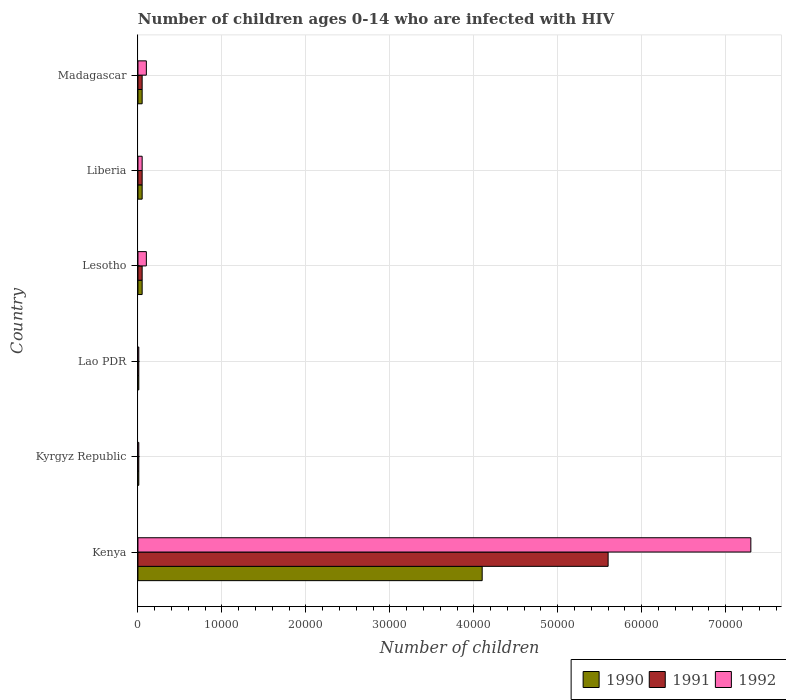How many different coloured bars are there?
Give a very brief answer. 3. Are the number of bars on each tick of the Y-axis equal?
Keep it short and to the point. Yes. What is the label of the 4th group of bars from the top?
Offer a very short reply. Lao PDR. In how many cases, is the number of bars for a given country not equal to the number of legend labels?
Ensure brevity in your answer.  0. What is the number of HIV infected children in 1991 in Kyrgyz Republic?
Keep it short and to the point. 100. Across all countries, what is the maximum number of HIV infected children in 1990?
Offer a terse response. 4.10e+04. Across all countries, what is the minimum number of HIV infected children in 1992?
Your answer should be very brief. 100. In which country was the number of HIV infected children in 1992 maximum?
Offer a very short reply. Kenya. In which country was the number of HIV infected children in 1991 minimum?
Offer a terse response. Kyrgyz Republic. What is the total number of HIV infected children in 1991 in the graph?
Your answer should be very brief. 5.77e+04. What is the difference between the number of HIV infected children in 1990 in Kenya and that in Lao PDR?
Your response must be concise. 4.09e+04. What is the difference between the number of HIV infected children in 1991 in Lao PDR and the number of HIV infected children in 1992 in Kenya?
Keep it short and to the point. -7.29e+04. What is the average number of HIV infected children in 1990 per country?
Keep it short and to the point. 7116.67. What is the difference between the number of HIV infected children in 1991 and number of HIV infected children in 1992 in Lesotho?
Your answer should be very brief. -500. In how many countries, is the number of HIV infected children in 1992 greater than 30000 ?
Provide a short and direct response. 1. What is the ratio of the number of HIV infected children in 1991 in Liberia to that in Madagascar?
Ensure brevity in your answer.  1. Is the difference between the number of HIV infected children in 1991 in Kenya and Liberia greater than the difference between the number of HIV infected children in 1992 in Kenya and Liberia?
Your answer should be compact. No. What is the difference between the highest and the second highest number of HIV infected children in 1992?
Your response must be concise. 7.20e+04. What is the difference between the highest and the lowest number of HIV infected children in 1992?
Your answer should be compact. 7.29e+04. In how many countries, is the number of HIV infected children in 1991 greater than the average number of HIV infected children in 1991 taken over all countries?
Keep it short and to the point. 1. What does the 1st bar from the top in Liberia represents?
Provide a succinct answer. 1992. What does the 1st bar from the bottom in Kyrgyz Republic represents?
Offer a terse response. 1990. Are the values on the major ticks of X-axis written in scientific E-notation?
Ensure brevity in your answer.  No. Where does the legend appear in the graph?
Ensure brevity in your answer.  Bottom right. How many legend labels are there?
Give a very brief answer. 3. How are the legend labels stacked?
Give a very brief answer. Horizontal. What is the title of the graph?
Keep it short and to the point. Number of children ages 0-14 who are infected with HIV. What is the label or title of the X-axis?
Offer a very short reply. Number of children. What is the Number of children of 1990 in Kenya?
Make the answer very short. 4.10e+04. What is the Number of children of 1991 in Kenya?
Provide a succinct answer. 5.60e+04. What is the Number of children of 1992 in Kenya?
Give a very brief answer. 7.30e+04. What is the Number of children in 1990 in Kyrgyz Republic?
Offer a terse response. 100. What is the Number of children in 1990 in Lao PDR?
Give a very brief answer. 100. What is the Number of children in 1991 in Lao PDR?
Offer a very short reply. 100. What is the Number of children in 1992 in Lao PDR?
Your response must be concise. 100. What is the Number of children of 1990 in Lesotho?
Keep it short and to the point. 500. What is the Number of children in 1992 in Lesotho?
Provide a succinct answer. 1000. What is the Number of children of 1991 in Liberia?
Keep it short and to the point. 500. What is the Number of children of 1990 in Madagascar?
Offer a very short reply. 500. What is the Number of children of 1991 in Madagascar?
Your response must be concise. 500. Across all countries, what is the maximum Number of children in 1990?
Keep it short and to the point. 4.10e+04. Across all countries, what is the maximum Number of children in 1991?
Give a very brief answer. 5.60e+04. Across all countries, what is the maximum Number of children in 1992?
Provide a short and direct response. 7.30e+04. What is the total Number of children of 1990 in the graph?
Offer a very short reply. 4.27e+04. What is the total Number of children in 1991 in the graph?
Offer a very short reply. 5.77e+04. What is the total Number of children in 1992 in the graph?
Provide a short and direct response. 7.57e+04. What is the difference between the Number of children of 1990 in Kenya and that in Kyrgyz Republic?
Make the answer very short. 4.09e+04. What is the difference between the Number of children of 1991 in Kenya and that in Kyrgyz Republic?
Keep it short and to the point. 5.59e+04. What is the difference between the Number of children in 1992 in Kenya and that in Kyrgyz Republic?
Offer a very short reply. 7.29e+04. What is the difference between the Number of children in 1990 in Kenya and that in Lao PDR?
Provide a succinct answer. 4.09e+04. What is the difference between the Number of children of 1991 in Kenya and that in Lao PDR?
Keep it short and to the point. 5.59e+04. What is the difference between the Number of children of 1992 in Kenya and that in Lao PDR?
Provide a short and direct response. 7.29e+04. What is the difference between the Number of children in 1990 in Kenya and that in Lesotho?
Keep it short and to the point. 4.05e+04. What is the difference between the Number of children of 1991 in Kenya and that in Lesotho?
Keep it short and to the point. 5.55e+04. What is the difference between the Number of children of 1992 in Kenya and that in Lesotho?
Your answer should be compact. 7.20e+04. What is the difference between the Number of children of 1990 in Kenya and that in Liberia?
Offer a terse response. 4.05e+04. What is the difference between the Number of children of 1991 in Kenya and that in Liberia?
Your response must be concise. 5.55e+04. What is the difference between the Number of children in 1992 in Kenya and that in Liberia?
Ensure brevity in your answer.  7.25e+04. What is the difference between the Number of children of 1990 in Kenya and that in Madagascar?
Your response must be concise. 4.05e+04. What is the difference between the Number of children in 1991 in Kenya and that in Madagascar?
Provide a succinct answer. 5.55e+04. What is the difference between the Number of children of 1992 in Kenya and that in Madagascar?
Make the answer very short. 7.20e+04. What is the difference between the Number of children of 1990 in Kyrgyz Republic and that in Lao PDR?
Your answer should be very brief. 0. What is the difference between the Number of children in 1990 in Kyrgyz Republic and that in Lesotho?
Provide a succinct answer. -400. What is the difference between the Number of children in 1991 in Kyrgyz Republic and that in Lesotho?
Offer a very short reply. -400. What is the difference between the Number of children of 1992 in Kyrgyz Republic and that in Lesotho?
Provide a succinct answer. -900. What is the difference between the Number of children in 1990 in Kyrgyz Republic and that in Liberia?
Your response must be concise. -400. What is the difference between the Number of children of 1991 in Kyrgyz Republic and that in Liberia?
Provide a short and direct response. -400. What is the difference between the Number of children of 1992 in Kyrgyz Republic and that in Liberia?
Provide a short and direct response. -400. What is the difference between the Number of children in 1990 in Kyrgyz Republic and that in Madagascar?
Your answer should be compact. -400. What is the difference between the Number of children of 1991 in Kyrgyz Republic and that in Madagascar?
Ensure brevity in your answer.  -400. What is the difference between the Number of children of 1992 in Kyrgyz Republic and that in Madagascar?
Your answer should be very brief. -900. What is the difference between the Number of children in 1990 in Lao PDR and that in Lesotho?
Offer a terse response. -400. What is the difference between the Number of children in 1991 in Lao PDR and that in Lesotho?
Offer a very short reply. -400. What is the difference between the Number of children of 1992 in Lao PDR and that in Lesotho?
Ensure brevity in your answer.  -900. What is the difference between the Number of children of 1990 in Lao PDR and that in Liberia?
Ensure brevity in your answer.  -400. What is the difference between the Number of children in 1991 in Lao PDR and that in Liberia?
Your response must be concise. -400. What is the difference between the Number of children of 1992 in Lao PDR and that in Liberia?
Offer a terse response. -400. What is the difference between the Number of children of 1990 in Lao PDR and that in Madagascar?
Your answer should be compact. -400. What is the difference between the Number of children of 1991 in Lao PDR and that in Madagascar?
Your answer should be very brief. -400. What is the difference between the Number of children of 1992 in Lao PDR and that in Madagascar?
Offer a very short reply. -900. What is the difference between the Number of children in 1992 in Lesotho and that in Liberia?
Your response must be concise. 500. What is the difference between the Number of children of 1991 in Lesotho and that in Madagascar?
Your answer should be very brief. 0. What is the difference between the Number of children of 1992 in Lesotho and that in Madagascar?
Provide a short and direct response. 0. What is the difference between the Number of children of 1990 in Liberia and that in Madagascar?
Your answer should be compact. 0. What is the difference between the Number of children of 1992 in Liberia and that in Madagascar?
Keep it short and to the point. -500. What is the difference between the Number of children of 1990 in Kenya and the Number of children of 1991 in Kyrgyz Republic?
Your response must be concise. 4.09e+04. What is the difference between the Number of children in 1990 in Kenya and the Number of children in 1992 in Kyrgyz Republic?
Offer a terse response. 4.09e+04. What is the difference between the Number of children of 1991 in Kenya and the Number of children of 1992 in Kyrgyz Republic?
Provide a short and direct response. 5.59e+04. What is the difference between the Number of children of 1990 in Kenya and the Number of children of 1991 in Lao PDR?
Offer a very short reply. 4.09e+04. What is the difference between the Number of children of 1990 in Kenya and the Number of children of 1992 in Lao PDR?
Ensure brevity in your answer.  4.09e+04. What is the difference between the Number of children in 1991 in Kenya and the Number of children in 1992 in Lao PDR?
Make the answer very short. 5.59e+04. What is the difference between the Number of children of 1990 in Kenya and the Number of children of 1991 in Lesotho?
Give a very brief answer. 4.05e+04. What is the difference between the Number of children in 1991 in Kenya and the Number of children in 1992 in Lesotho?
Ensure brevity in your answer.  5.50e+04. What is the difference between the Number of children in 1990 in Kenya and the Number of children in 1991 in Liberia?
Give a very brief answer. 4.05e+04. What is the difference between the Number of children in 1990 in Kenya and the Number of children in 1992 in Liberia?
Offer a very short reply. 4.05e+04. What is the difference between the Number of children in 1991 in Kenya and the Number of children in 1992 in Liberia?
Ensure brevity in your answer.  5.55e+04. What is the difference between the Number of children of 1990 in Kenya and the Number of children of 1991 in Madagascar?
Your answer should be compact. 4.05e+04. What is the difference between the Number of children in 1991 in Kenya and the Number of children in 1992 in Madagascar?
Offer a terse response. 5.50e+04. What is the difference between the Number of children in 1990 in Kyrgyz Republic and the Number of children in 1991 in Lao PDR?
Offer a very short reply. 0. What is the difference between the Number of children in 1990 in Kyrgyz Republic and the Number of children in 1992 in Lao PDR?
Provide a short and direct response. 0. What is the difference between the Number of children in 1991 in Kyrgyz Republic and the Number of children in 1992 in Lao PDR?
Provide a succinct answer. 0. What is the difference between the Number of children in 1990 in Kyrgyz Republic and the Number of children in 1991 in Lesotho?
Give a very brief answer. -400. What is the difference between the Number of children of 1990 in Kyrgyz Republic and the Number of children of 1992 in Lesotho?
Make the answer very short. -900. What is the difference between the Number of children of 1991 in Kyrgyz Republic and the Number of children of 1992 in Lesotho?
Your answer should be compact. -900. What is the difference between the Number of children in 1990 in Kyrgyz Republic and the Number of children in 1991 in Liberia?
Give a very brief answer. -400. What is the difference between the Number of children in 1990 in Kyrgyz Republic and the Number of children in 1992 in Liberia?
Make the answer very short. -400. What is the difference between the Number of children in 1991 in Kyrgyz Republic and the Number of children in 1992 in Liberia?
Give a very brief answer. -400. What is the difference between the Number of children in 1990 in Kyrgyz Republic and the Number of children in 1991 in Madagascar?
Your response must be concise. -400. What is the difference between the Number of children of 1990 in Kyrgyz Republic and the Number of children of 1992 in Madagascar?
Provide a short and direct response. -900. What is the difference between the Number of children of 1991 in Kyrgyz Republic and the Number of children of 1992 in Madagascar?
Your answer should be very brief. -900. What is the difference between the Number of children of 1990 in Lao PDR and the Number of children of 1991 in Lesotho?
Your answer should be compact. -400. What is the difference between the Number of children in 1990 in Lao PDR and the Number of children in 1992 in Lesotho?
Offer a terse response. -900. What is the difference between the Number of children in 1991 in Lao PDR and the Number of children in 1992 in Lesotho?
Offer a very short reply. -900. What is the difference between the Number of children in 1990 in Lao PDR and the Number of children in 1991 in Liberia?
Offer a terse response. -400. What is the difference between the Number of children in 1990 in Lao PDR and the Number of children in 1992 in Liberia?
Ensure brevity in your answer.  -400. What is the difference between the Number of children in 1991 in Lao PDR and the Number of children in 1992 in Liberia?
Provide a short and direct response. -400. What is the difference between the Number of children in 1990 in Lao PDR and the Number of children in 1991 in Madagascar?
Provide a short and direct response. -400. What is the difference between the Number of children in 1990 in Lao PDR and the Number of children in 1992 in Madagascar?
Your response must be concise. -900. What is the difference between the Number of children in 1991 in Lao PDR and the Number of children in 1992 in Madagascar?
Offer a very short reply. -900. What is the difference between the Number of children of 1990 in Lesotho and the Number of children of 1992 in Madagascar?
Ensure brevity in your answer.  -500. What is the difference between the Number of children in 1991 in Lesotho and the Number of children in 1992 in Madagascar?
Provide a short and direct response. -500. What is the difference between the Number of children of 1990 in Liberia and the Number of children of 1991 in Madagascar?
Give a very brief answer. 0. What is the difference between the Number of children of 1990 in Liberia and the Number of children of 1992 in Madagascar?
Give a very brief answer. -500. What is the difference between the Number of children of 1991 in Liberia and the Number of children of 1992 in Madagascar?
Your answer should be very brief. -500. What is the average Number of children of 1990 per country?
Keep it short and to the point. 7116.67. What is the average Number of children of 1991 per country?
Provide a short and direct response. 9616.67. What is the average Number of children of 1992 per country?
Provide a short and direct response. 1.26e+04. What is the difference between the Number of children in 1990 and Number of children in 1991 in Kenya?
Offer a terse response. -1.50e+04. What is the difference between the Number of children of 1990 and Number of children of 1992 in Kenya?
Offer a very short reply. -3.20e+04. What is the difference between the Number of children in 1991 and Number of children in 1992 in Kenya?
Offer a very short reply. -1.70e+04. What is the difference between the Number of children of 1991 and Number of children of 1992 in Kyrgyz Republic?
Your response must be concise. 0. What is the difference between the Number of children in 1990 and Number of children in 1991 in Lao PDR?
Make the answer very short. 0. What is the difference between the Number of children in 1990 and Number of children in 1991 in Lesotho?
Your answer should be very brief. 0. What is the difference between the Number of children of 1990 and Number of children of 1992 in Lesotho?
Ensure brevity in your answer.  -500. What is the difference between the Number of children in 1991 and Number of children in 1992 in Lesotho?
Provide a succinct answer. -500. What is the difference between the Number of children of 1990 and Number of children of 1991 in Liberia?
Your answer should be compact. 0. What is the difference between the Number of children in 1991 and Number of children in 1992 in Liberia?
Provide a succinct answer. 0. What is the difference between the Number of children of 1990 and Number of children of 1991 in Madagascar?
Ensure brevity in your answer.  0. What is the difference between the Number of children of 1990 and Number of children of 1992 in Madagascar?
Your answer should be compact. -500. What is the difference between the Number of children of 1991 and Number of children of 1992 in Madagascar?
Offer a very short reply. -500. What is the ratio of the Number of children in 1990 in Kenya to that in Kyrgyz Republic?
Your response must be concise. 410. What is the ratio of the Number of children of 1991 in Kenya to that in Kyrgyz Republic?
Offer a terse response. 560. What is the ratio of the Number of children in 1992 in Kenya to that in Kyrgyz Republic?
Keep it short and to the point. 730. What is the ratio of the Number of children in 1990 in Kenya to that in Lao PDR?
Your answer should be very brief. 410. What is the ratio of the Number of children in 1991 in Kenya to that in Lao PDR?
Offer a very short reply. 560. What is the ratio of the Number of children of 1992 in Kenya to that in Lao PDR?
Make the answer very short. 730. What is the ratio of the Number of children of 1990 in Kenya to that in Lesotho?
Your response must be concise. 82. What is the ratio of the Number of children in 1991 in Kenya to that in Lesotho?
Your answer should be very brief. 112. What is the ratio of the Number of children of 1991 in Kenya to that in Liberia?
Provide a succinct answer. 112. What is the ratio of the Number of children of 1992 in Kenya to that in Liberia?
Make the answer very short. 146. What is the ratio of the Number of children in 1991 in Kenya to that in Madagascar?
Make the answer very short. 112. What is the ratio of the Number of children of 1992 in Kenya to that in Madagascar?
Offer a terse response. 73. What is the ratio of the Number of children of 1990 in Kyrgyz Republic to that in Lao PDR?
Your answer should be very brief. 1. What is the ratio of the Number of children in 1991 in Kyrgyz Republic to that in Lao PDR?
Provide a succinct answer. 1. What is the ratio of the Number of children in 1990 in Kyrgyz Republic to that in Lesotho?
Provide a succinct answer. 0.2. What is the ratio of the Number of children in 1992 in Kyrgyz Republic to that in Liberia?
Make the answer very short. 0.2. What is the ratio of the Number of children of 1990 in Kyrgyz Republic to that in Madagascar?
Ensure brevity in your answer.  0.2. What is the ratio of the Number of children in 1991 in Kyrgyz Republic to that in Madagascar?
Make the answer very short. 0.2. What is the ratio of the Number of children in 1992 in Lao PDR to that in Lesotho?
Your answer should be very brief. 0.1. What is the ratio of the Number of children in 1991 in Lao PDR to that in Liberia?
Give a very brief answer. 0.2. What is the ratio of the Number of children of 1991 in Lao PDR to that in Madagascar?
Make the answer very short. 0.2. What is the ratio of the Number of children of 1992 in Lao PDR to that in Madagascar?
Offer a very short reply. 0.1. What is the ratio of the Number of children of 1991 in Lesotho to that in Liberia?
Provide a short and direct response. 1. What is the ratio of the Number of children of 1992 in Lesotho to that in Liberia?
Your answer should be very brief. 2. What is the ratio of the Number of children of 1992 in Lesotho to that in Madagascar?
Your response must be concise. 1. What is the ratio of the Number of children in 1990 in Liberia to that in Madagascar?
Ensure brevity in your answer.  1. What is the ratio of the Number of children of 1991 in Liberia to that in Madagascar?
Your answer should be compact. 1. What is the ratio of the Number of children in 1992 in Liberia to that in Madagascar?
Give a very brief answer. 0.5. What is the difference between the highest and the second highest Number of children in 1990?
Keep it short and to the point. 4.05e+04. What is the difference between the highest and the second highest Number of children in 1991?
Offer a terse response. 5.55e+04. What is the difference between the highest and the second highest Number of children of 1992?
Give a very brief answer. 7.20e+04. What is the difference between the highest and the lowest Number of children in 1990?
Make the answer very short. 4.09e+04. What is the difference between the highest and the lowest Number of children in 1991?
Offer a very short reply. 5.59e+04. What is the difference between the highest and the lowest Number of children of 1992?
Give a very brief answer. 7.29e+04. 